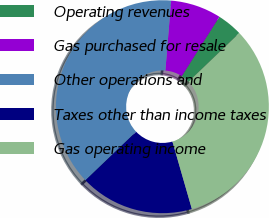Convert chart. <chart><loc_0><loc_0><loc_500><loc_500><pie_chart><fcel>Operating revenues<fcel>Gas purchased for resale<fcel>Other operations and<fcel>Taxes other than income taxes<fcel>Gas operating income<nl><fcel>3.85%<fcel>7.69%<fcel>38.46%<fcel>17.31%<fcel>32.69%<nl></chart> 